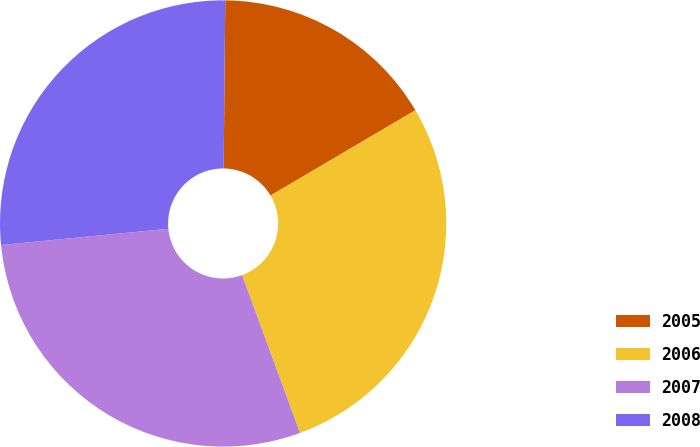Convert chart. <chart><loc_0><loc_0><loc_500><loc_500><pie_chart><fcel>2005<fcel>2006<fcel>2007<fcel>2008<nl><fcel>16.38%<fcel>27.87%<fcel>29.06%<fcel>26.69%<nl></chart> 